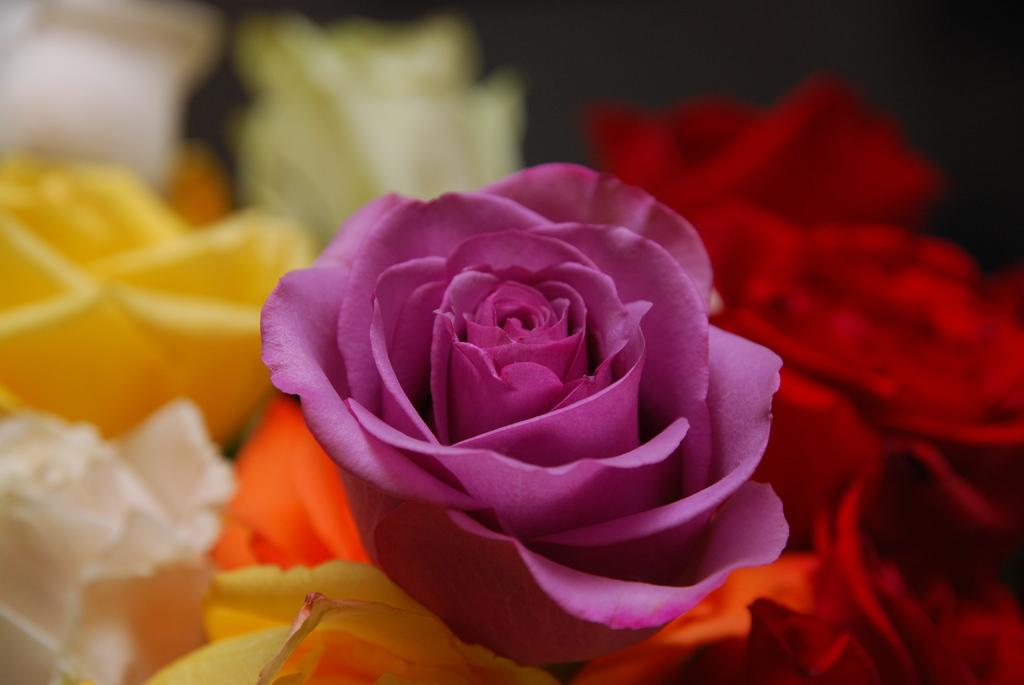What type of living organisms can be seen in the image? There are flowers in the image. Can you describe the flowers in the image? The flowers are of different colors. What type of protest is being held by the wren in the image? There is no wren present in the image, and therefore no protest can be observed. 